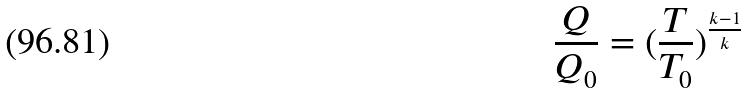Convert formula to latex. <formula><loc_0><loc_0><loc_500><loc_500>\frac { Q } { Q _ { 0 } } = ( \frac { T } { T _ { 0 } } ) ^ { \frac { k - 1 } { k } }</formula> 